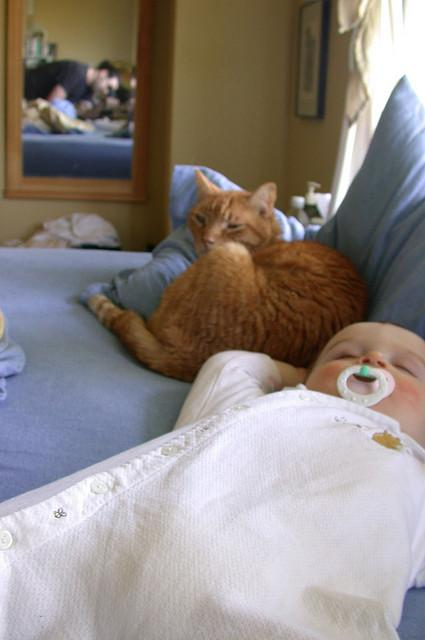How many different living creatures are visible here? three 